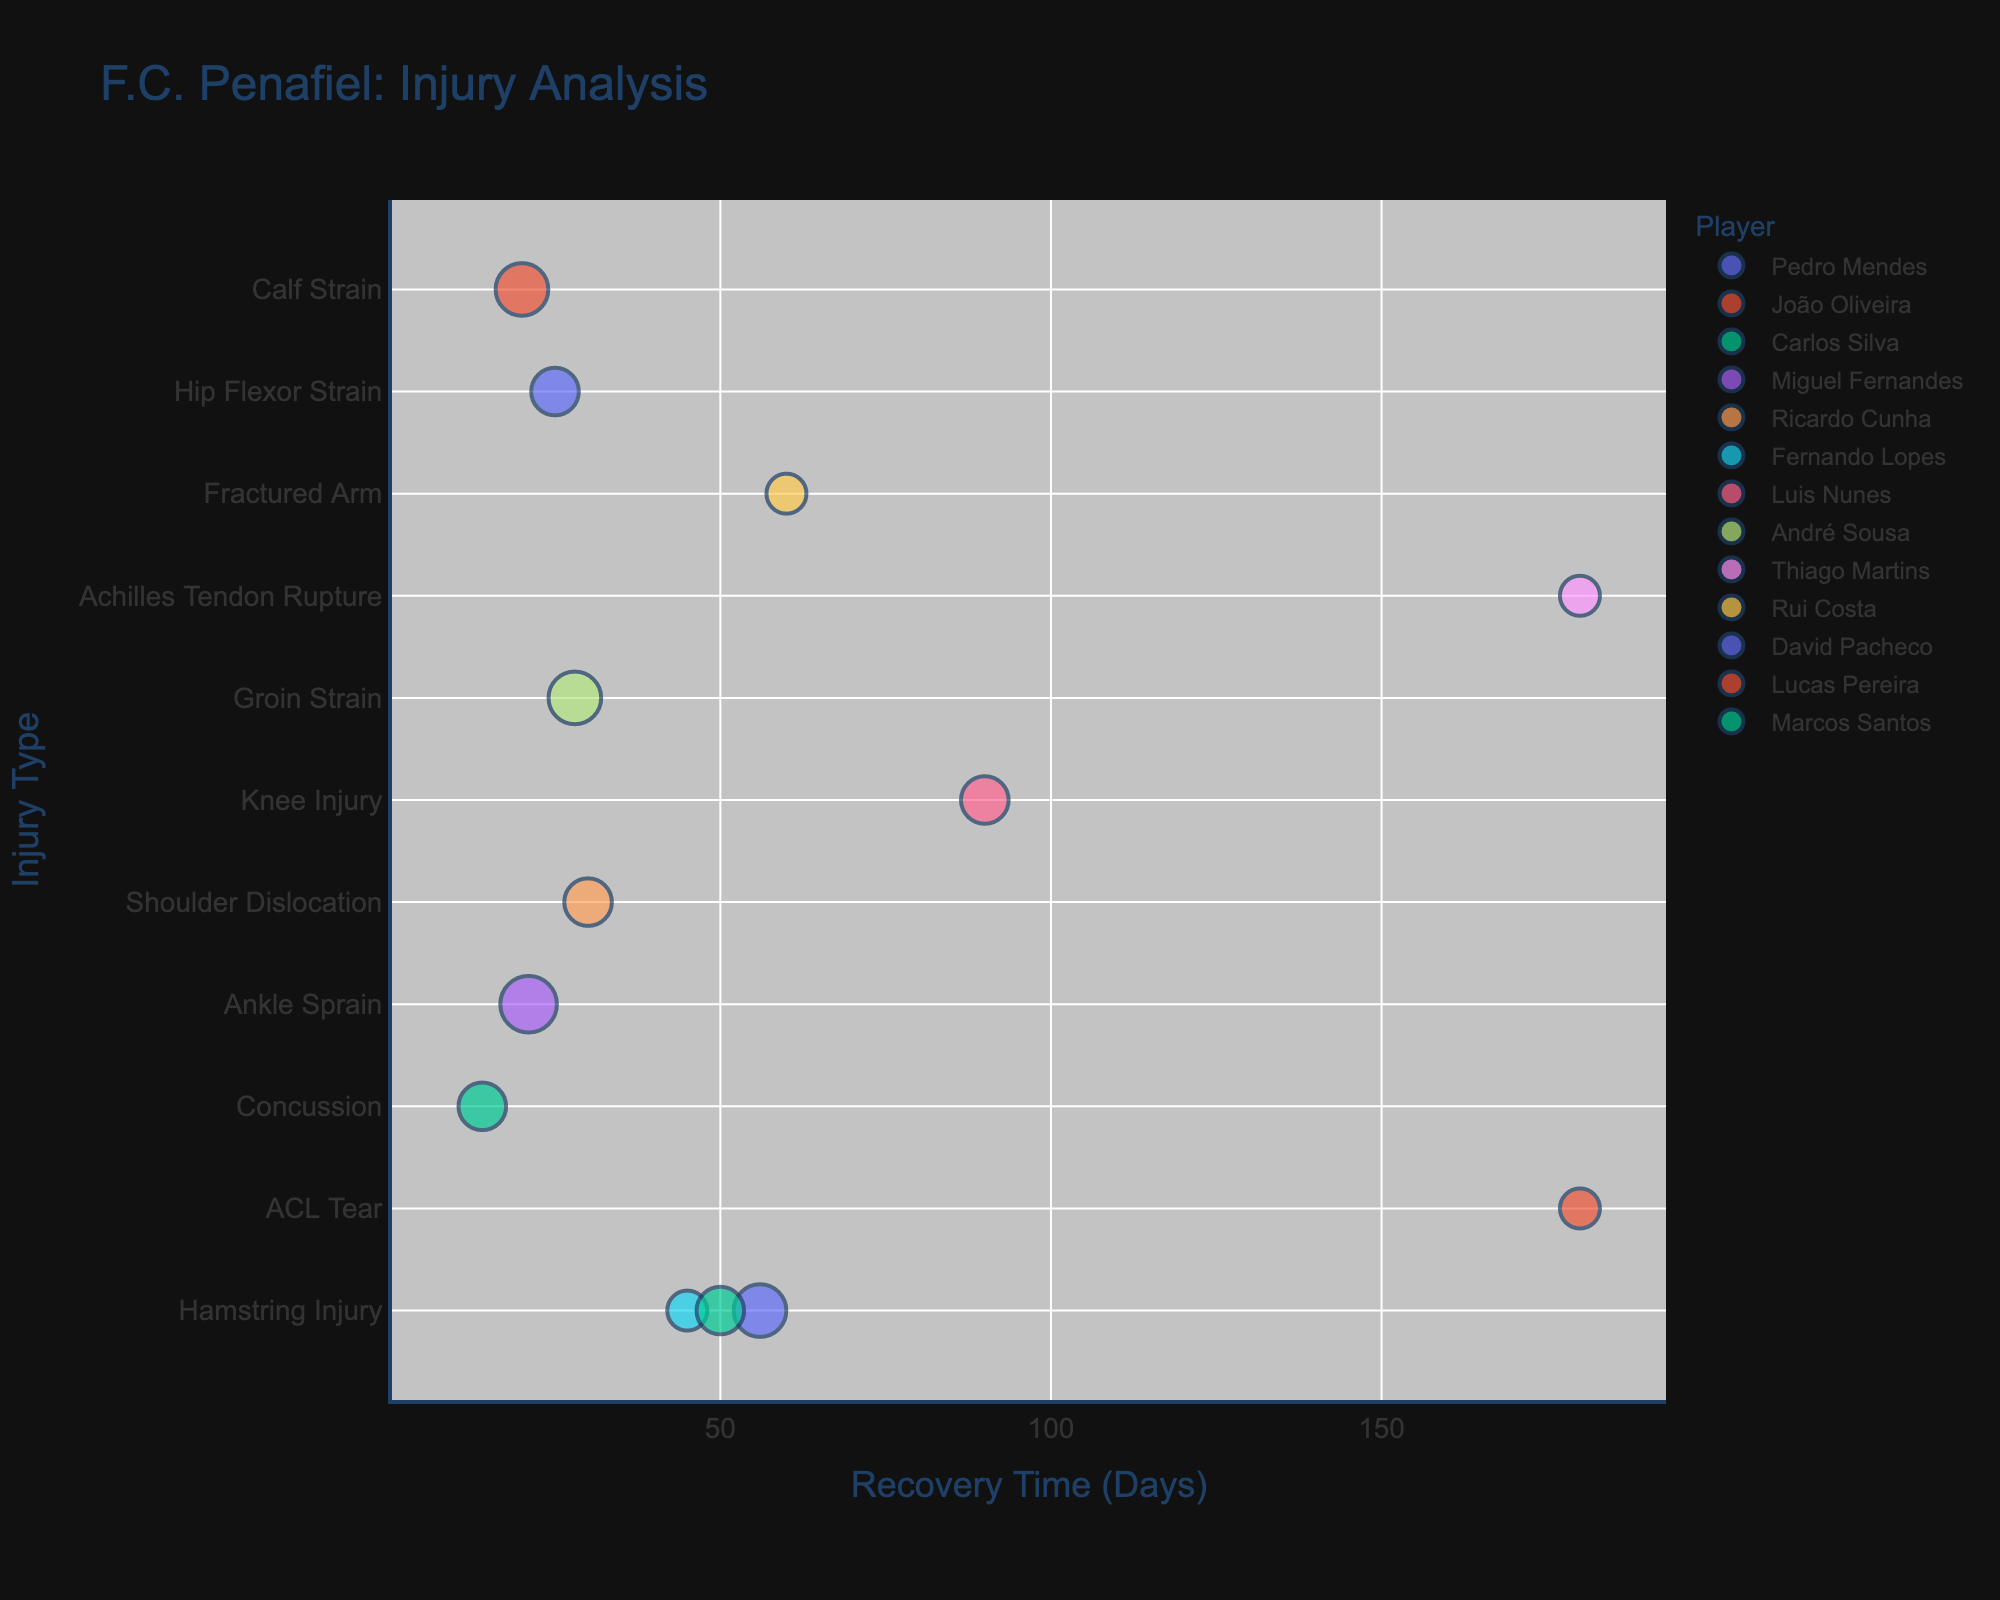How many players had an ACL Tear injury? By observing the bubble chart and looking for the 'ACL Tear' label on the y-axis, we can count how many players are associated with this injury type.
Answer: 1 Which injury had the longest recovery time and how many days did it last? By looking at the bubble chart and identifying the highest value on the x-axis (Recovery Time), we can find the injury with the longest recovery time by matching it to the corresponding y-axis label.
Answer: ACL Tear, 180 days Which player had the most injuries in total? By identifying the size of the bubbles (indicative of the number of injuries) and cross-referencing with the player names, we can determine which player has the largest bubble.
Answer: Miguel Fernandes What is the total number of injuries recorded for all players combined? Summing up the 'Number of Injuries' column from the provided data table gives us the total number of injuries across all players.
Answer: 24 What is the average recovery time for hamstring injuries? Identify and sum up the recovery times for all hamstring injuries and then divide by the number of hamstring injuries. The data contains: Pedro Mendes (56 days), Fernando Lopes (45 days), and Marcos Santos (50 days). The sum is 151, and there are 3 instances. Thus, the average is 151/3.
Answer: 50.33 days Which injury type had the highest variety of recovery times, and what were those times? Checking the y-axis for injury types and counting the different recovery times for each, we identify which injury type has the most unique recovery time values. Hamstring injury recovery times vary (56, 45, 50).
Answer: Hamstring Injury, 45, 50, 56 days Which two players had the same type of injury for the same duration? By comparing both the 'Injury Type' and 'Injury Duration (Days)' columns across the data, we look for matching entries.
Answer: Ricardo Cunha and Carlos Silva, 30 days How many types of injuries did 'André Sousa' suffer, and what were their durations? Locate 'André Sousa' in the bubble chart and list the different injury types and their respective durations. André Sousa has 3 injuries of 'Groin Strain' lasting 28 days each.
Answer: 1 type, 28 days each What is the total recovery time needed if all of Lucas Pereira’s Calf Strains are added together? Multiply the 'Injury Duration (Days)' for Lucas Pereira by the 'Number of Injuries'. For 20 days and 3 injuries, the total recovery time would be 20 * 3.
Answer: 60 days Which injury had only one occurrence across all players and how long was its recovery time? By identifying any injury type that appears only once in the bubble chart, then noting its corresponding recovery time. Achilles Tendon Rupture occurs once with a recovery time of 180 days.
Answer: Achilles Tendon Rupture, 180 days 